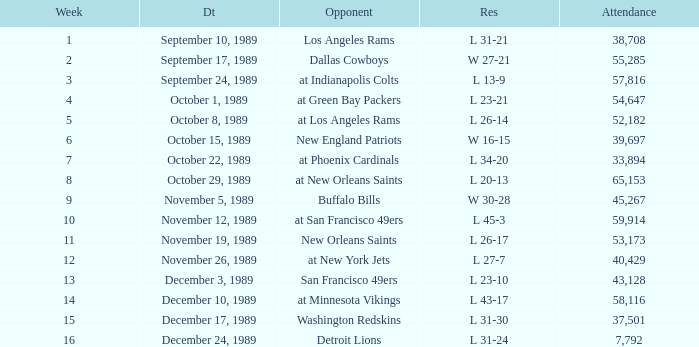The Detroit Lions were played against what week? 16.0. 